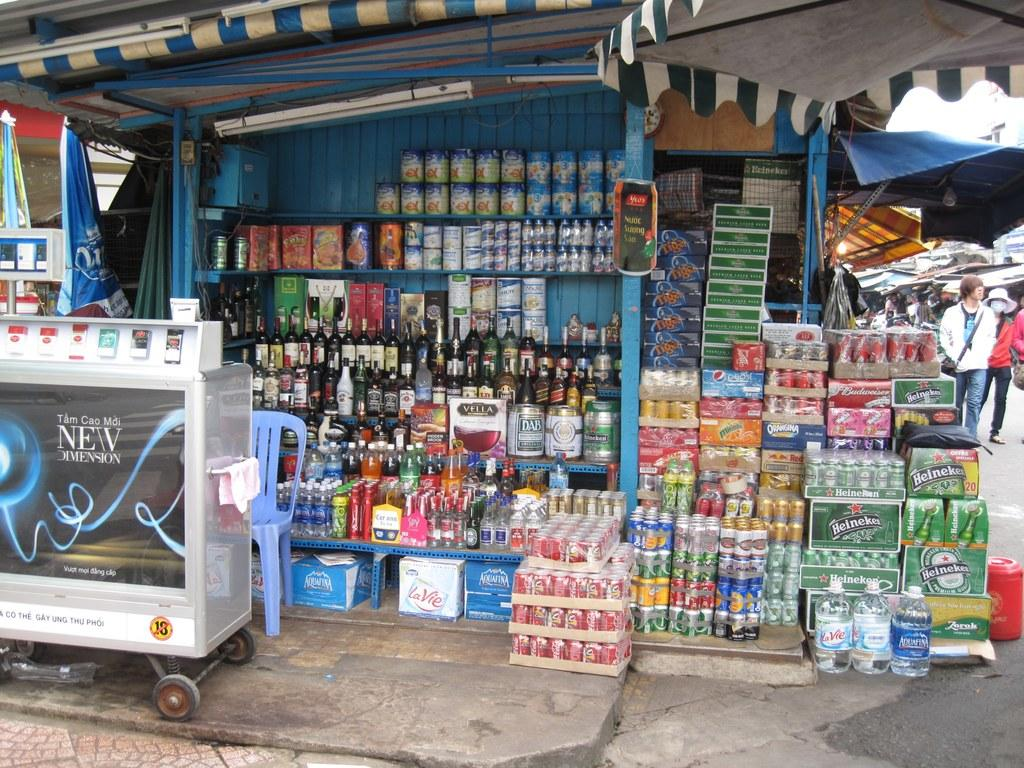<image>
Create a compact narrative representing the image presented. A store on a street, the words New Dimension can be seen to the left. 